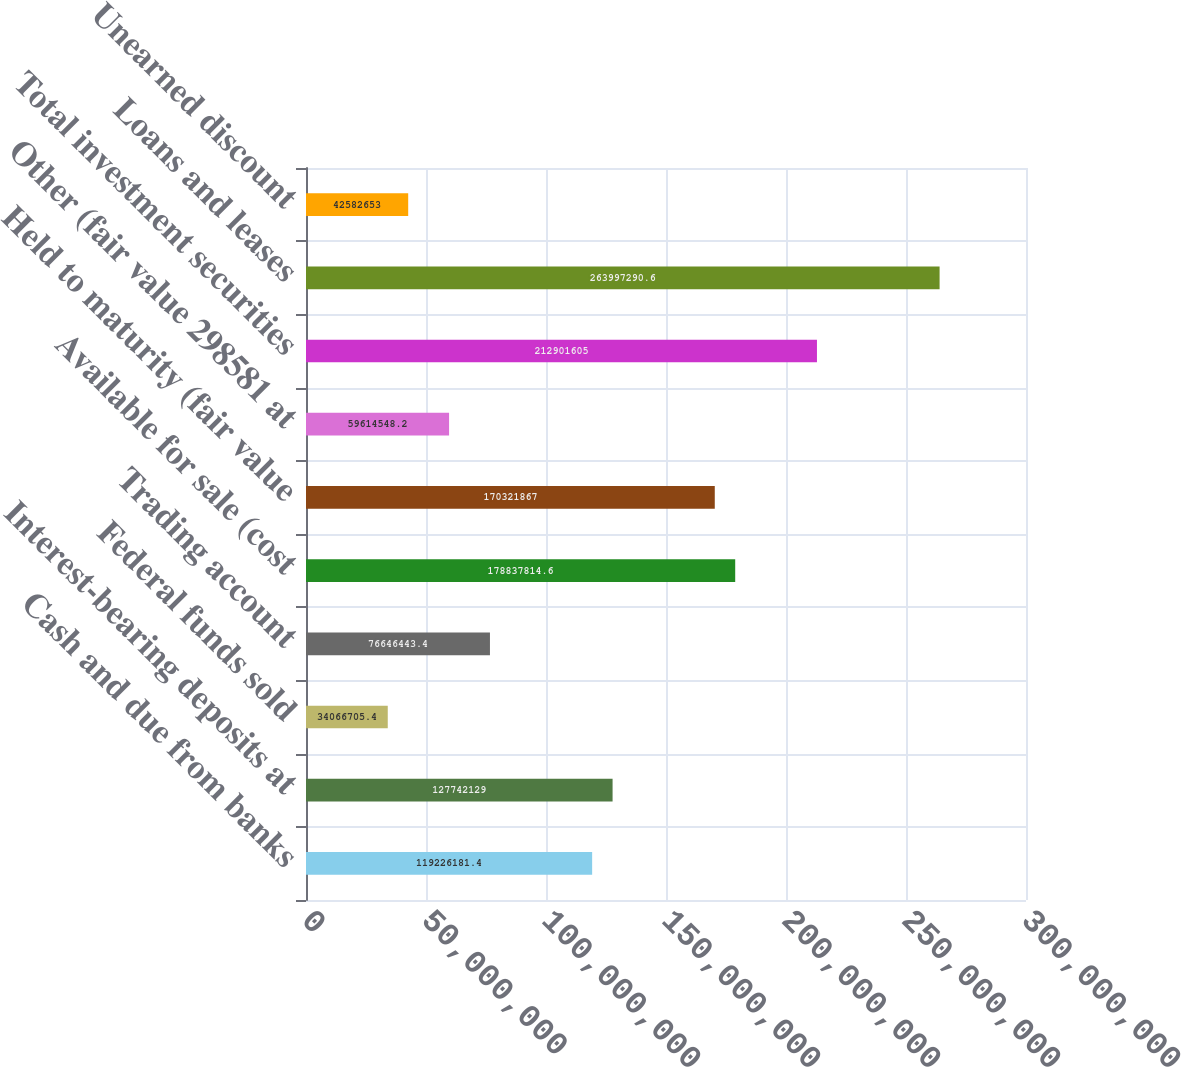Convert chart to OTSL. <chart><loc_0><loc_0><loc_500><loc_500><bar_chart><fcel>Cash and due from banks<fcel>Interest-bearing deposits at<fcel>Federal funds sold<fcel>Trading account<fcel>Available for sale (cost<fcel>Held to maturity (fair value<fcel>Other (fair value 298581 at<fcel>Total investment securities<fcel>Loans and leases<fcel>Unearned discount<nl><fcel>1.19226e+08<fcel>1.27742e+08<fcel>3.40667e+07<fcel>7.66464e+07<fcel>1.78838e+08<fcel>1.70322e+08<fcel>5.96145e+07<fcel>2.12902e+08<fcel>2.63997e+08<fcel>4.25827e+07<nl></chart> 